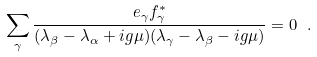Convert formula to latex. <formula><loc_0><loc_0><loc_500><loc_500>\sum _ { \gamma } \frac { e _ { \gamma } f _ { \gamma } ^ { * } } { ( \lambda _ { \beta } - \lambda _ { \alpha } + i g \mu ) ( \lambda _ { \gamma } - \lambda _ { \beta } - i g \mu ) } = 0 \ .</formula> 